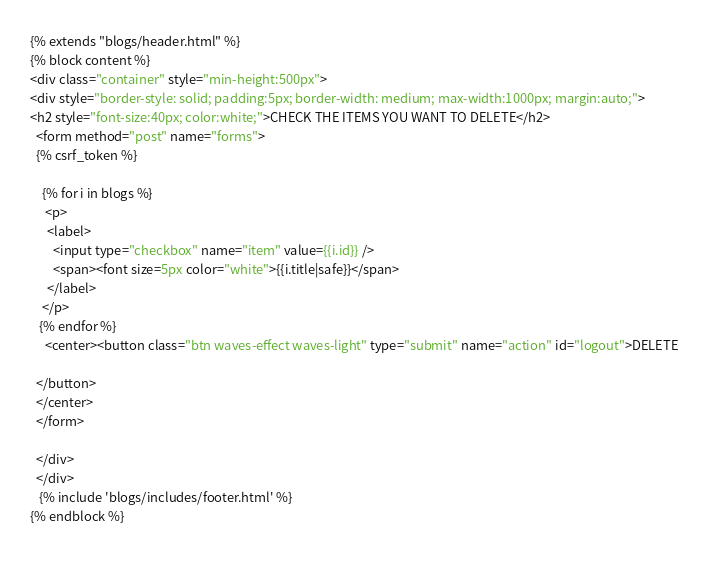Convert code to text. <code><loc_0><loc_0><loc_500><loc_500><_HTML_>
{% extends "blogs/header.html" %}
{% block content %}
<div class="container" style="min-height:500px">
<div style="border-style: solid; padding:5px; border-width: medium; max-width:1000px; margin:auto;">
<h2 style="font-size:40px; color:white;">CHECK THE ITEMS YOU WANT TO DELETE</h2>
  <form method="post" name="forms">
  {% csrf_token %}
   
    {% for i in blogs %}
     <p>
      <label>
        <input type="checkbox" name="item" value={{i.id}} />
        <span><font size=5px color="white">{{i.title|safe}}</span>
      </label>
    </p>
   {% endfor %}
     <center><button class="btn waves-effect waves-light" type="submit" name="action" id="logout">DELETE
  
  </button>
  </center>
  </form>
       
  </div>
  </div>
   {% include 'blogs/includes/footer.html' %}  
{% endblock %}
   </code> 